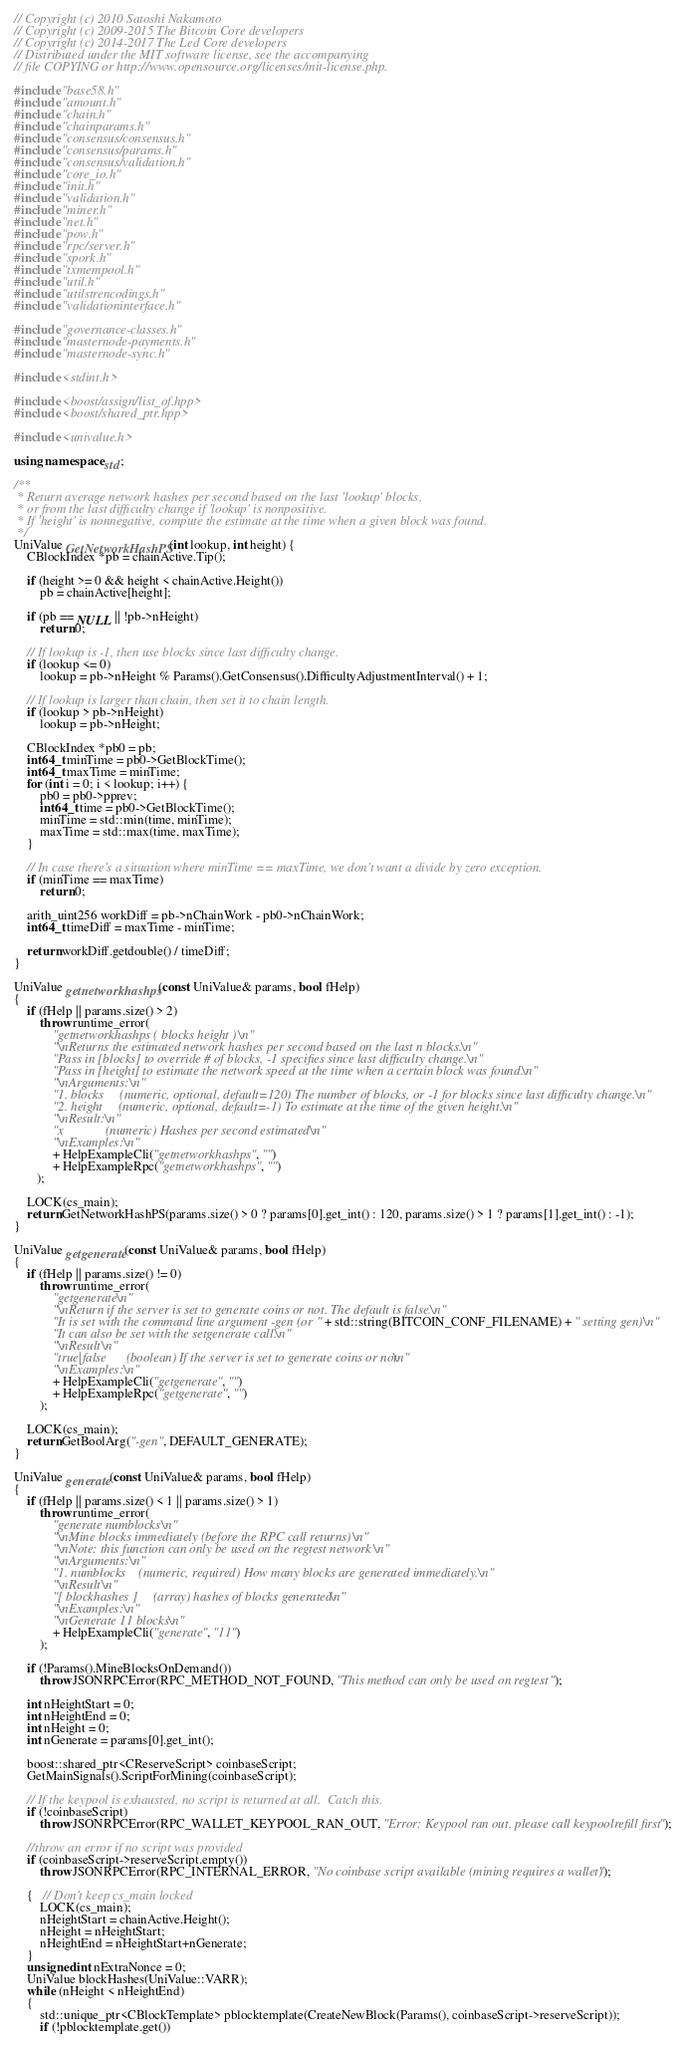Convert code to text. <code><loc_0><loc_0><loc_500><loc_500><_C++_>// Copyright (c) 2010 Satoshi Nakamoto
// Copyright (c) 2009-2015 The Bitcoin Core developers
// Copyright (c) 2014-2017 The Led Core developers
// Distributed under the MIT software license, see the accompanying
// file COPYING or http://www.opensource.org/licenses/mit-license.php.

#include "base58.h"
#include "amount.h"
#include "chain.h"
#include "chainparams.h"
#include "consensus/consensus.h"
#include "consensus/params.h"
#include "consensus/validation.h"
#include "core_io.h"
#include "init.h"
#include "validation.h"
#include "miner.h"
#include "net.h"
#include "pow.h"
#include "rpc/server.h"
#include "spork.h"
#include "txmempool.h"
#include "util.h"
#include "utilstrencodings.h"
#include "validationinterface.h"

#include "governance-classes.h"
#include "masternode-payments.h"
#include "masternode-sync.h"

#include <stdint.h>

#include <boost/assign/list_of.hpp>
#include <boost/shared_ptr.hpp>

#include <univalue.h>

using namespace std;

/**
 * Return average network hashes per second based on the last 'lookup' blocks,
 * or from the last difficulty change if 'lookup' is nonpositive.
 * If 'height' is nonnegative, compute the estimate at the time when a given block was found.
 */
UniValue GetNetworkHashPS(int lookup, int height) {
    CBlockIndex *pb = chainActive.Tip();

    if (height >= 0 && height < chainActive.Height())
        pb = chainActive[height];

    if (pb == NULL || !pb->nHeight)
        return 0;

    // If lookup is -1, then use blocks since last difficulty change.
    if (lookup <= 0)
        lookup = pb->nHeight % Params().GetConsensus().DifficultyAdjustmentInterval() + 1;

    // If lookup is larger than chain, then set it to chain length.
    if (lookup > pb->nHeight)
        lookup = pb->nHeight;

    CBlockIndex *pb0 = pb;
    int64_t minTime = pb0->GetBlockTime();
    int64_t maxTime = minTime;
    for (int i = 0; i < lookup; i++) {
        pb0 = pb0->pprev;
        int64_t time = pb0->GetBlockTime();
        minTime = std::min(time, minTime);
        maxTime = std::max(time, maxTime);
    }

    // In case there's a situation where minTime == maxTime, we don't want a divide by zero exception.
    if (minTime == maxTime)
        return 0;

    arith_uint256 workDiff = pb->nChainWork - pb0->nChainWork;
    int64_t timeDiff = maxTime - minTime;

    return workDiff.getdouble() / timeDiff;
}

UniValue getnetworkhashps(const UniValue& params, bool fHelp)
{
    if (fHelp || params.size() > 2)
        throw runtime_error(
            "getnetworkhashps ( blocks height )\n"
            "\nReturns the estimated network hashes per second based on the last n blocks.\n"
            "Pass in [blocks] to override # of blocks, -1 specifies since last difficulty change.\n"
            "Pass in [height] to estimate the network speed at the time when a certain block was found.\n"
            "\nArguments:\n"
            "1. blocks     (numeric, optional, default=120) The number of blocks, or -1 for blocks since last difficulty change.\n"
            "2. height     (numeric, optional, default=-1) To estimate at the time of the given height.\n"
            "\nResult:\n"
            "x             (numeric) Hashes per second estimated\n"
            "\nExamples:\n"
            + HelpExampleCli("getnetworkhashps", "")
            + HelpExampleRpc("getnetworkhashps", "")
       );

    LOCK(cs_main);
    return GetNetworkHashPS(params.size() > 0 ? params[0].get_int() : 120, params.size() > 1 ? params[1].get_int() : -1);
}

UniValue getgenerate(const UniValue& params, bool fHelp)
{
    if (fHelp || params.size() != 0)
        throw runtime_error(
            "getgenerate\n"
            "\nReturn if the server is set to generate coins or not. The default is false.\n"
            "It is set with the command line argument -gen (or " + std::string(BITCOIN_CONF_FILENAME) + " setting gen)\n"
            "It can also be set with the setgenerate call.\n"
            "\nResult\n"
            "true|false      (boolean) If the server is set to generate coins or not\n"
            "\nExamples:\n"
            + HelpExampleCli("getgenerate", "")
            + HelpExampleRpc("getgenerate", "")
        );

    LOCK(cs_main);
    return GetBoolArg("-gen", DEFAULT_GENERATE);
}

UniValue generate(const UniValue& params, bool fHelp)
{
    if (fHelp || params.size() < 1 || params.size() > 1)
        throw runtime_error(
            "generate numblocks\n"
            "\nMine blocks immediately (before the RPC call returns)\n"
            "\nNote: this function can only be used on the regtest network\n"
            "\nArguments:\n"
            "1. numblocks    (numeric, required) How many blocks are generated immediately.\n"
            "\nResult\n"
            "[ blockhashes ]     (array) hashes of blocks generated\n"
            "\nExamples:\n"
            "\nGenerate 11 blocks\n"
            + HelpExampleCli("generate", "11")
        );

    if (!Params().MineBlocksOnDemand())
        throw JSONRPCError(RPC_METHOD_NOT_FOUND, "This method can only be used on regtest");

    int nHeightStart = 0;
    int nHeightEnd = 0;
    int nHeight = 0;
    int nGenerate = params[0].get_int();

    boost::shared_ptr<CReserveScript> coinbaseScript;
    GetMainSignals().ScriptForMining(coinbaseScript);

    // If the keypool is exhausted, no script is returned at all.  Catch this.
    if (!coinbaseScript)
        throw JSONRPCError(RPC_WALLET_KEYPOOL_RAN_OUT, "Error: Keypool ran out, please call keypoolrefill first");

    //throw an error if no script was provided
    if (coinbaseScript->reserveScript.empty())
        throw JSONRPCError(RPC_INTERNAL_ERROR, "No coinbase script available (mining requires a wallet)");

    {   // Don't keep cs_main locked
        LOCK(cs_main);
        nHeightStart = chainActive.Height();
        nHeight = nHeightStart;
        nHeightEnd = nHeightStart+nGenerate;
    }
    unsigned int nExtraNonce = 0;
    UniValue blockHashes(UniValue::VARR);
    while (nHeight < nHeightEnd)
    {
        std::unique_ptr<CBlockTemplate> pblocktemplate(CreateNewBlock(Params(), coinbaseScript->reserveScript));
        if (!pblocktemplate.get())</code> 